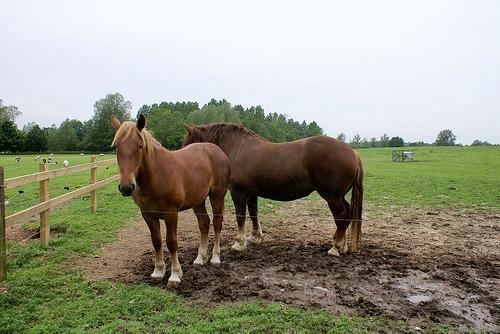How many horses are in the picture?
Give a very brief answer. 2. 